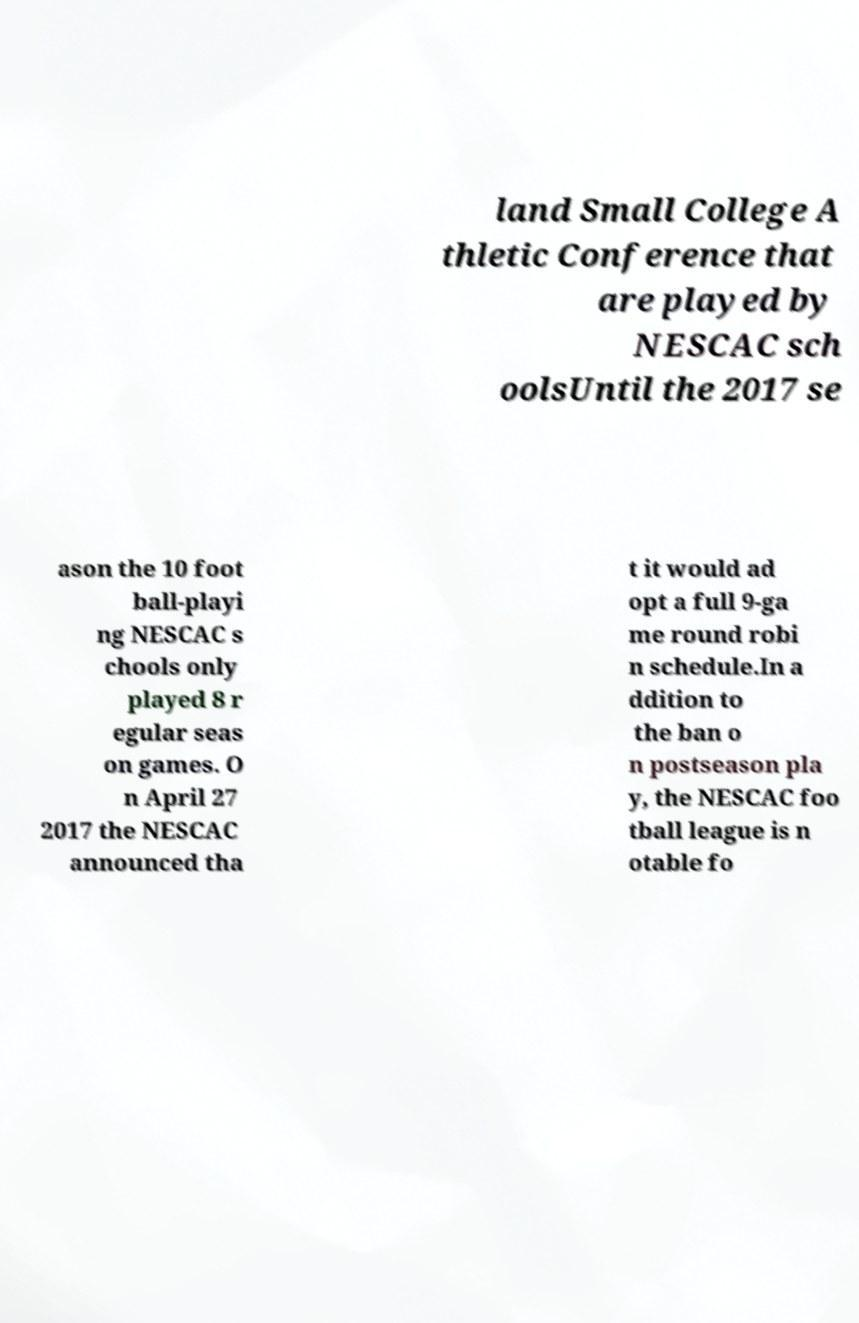Can you accurately transcribe the text from the provided image for me? land Small College A thletic Conference that are played by NESCAC sch oolsUntil the 2017 se ason the 10 foot ball-playi ng NESCAC s chools only played 8 r egular seas on games. O n April 27 2017 the NESCAC announced tha t it would ad opt a full 9-ga me round robi n schedule.In a ddition to the ban o n postseason pla y, the NESCAC foo tball league is n otable fo 